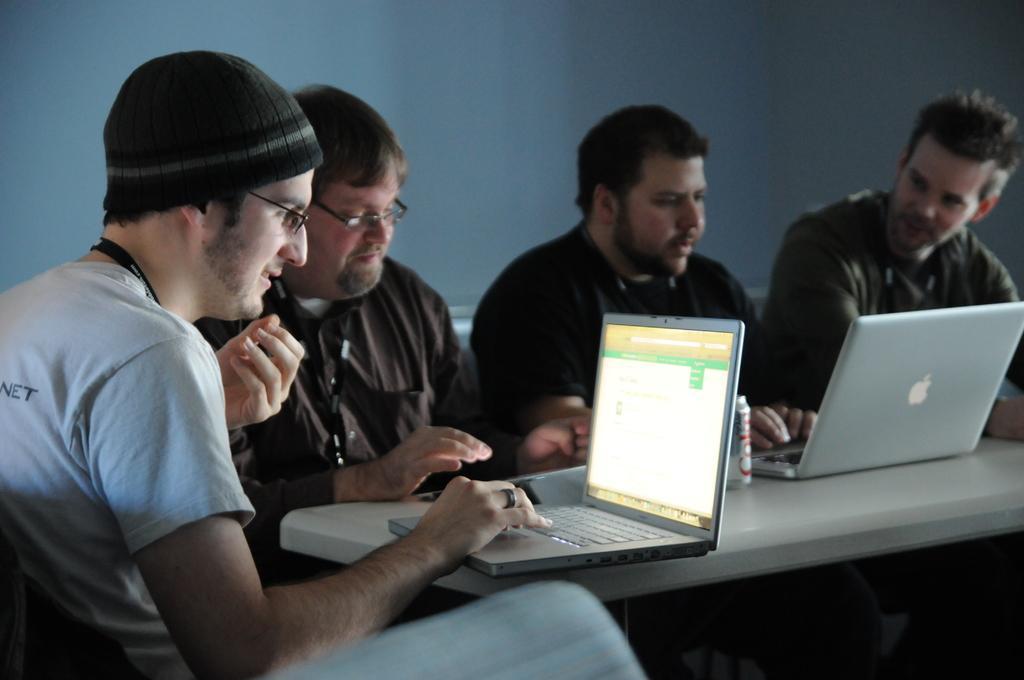Describe this image in one or two sentences. In this image we can see a few people sitting, in front of them there is a table, on the table, we can see two laptops and a tin, in the background we can see a wall. 